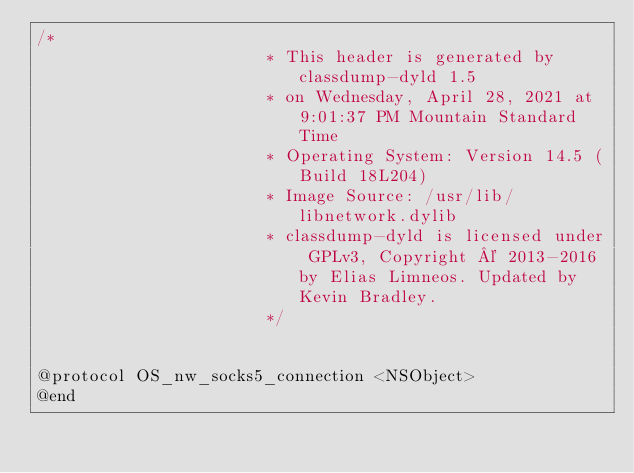Convert code to text. <code><loc_0><loc_0><loc_500><loc_500><_C_>/*
                       * This header is generated by classdump-dyld 1.5
                       * on Wednesday, April 28, 2021 at 9:01:37 PM Mountain Standard Time
                       * Operating System: Version 14.5 (Build 18L204)
                       * Image Source: /usr/lib/libnetwork.dylib
                       * classdump-dyld is licensed under GPLv3, Copyright © 2013-2016 by Elias Limneos. Updated by Kevin Bradley.
                       */


@protocol OS_nw_socks5_connection <NSObject>
@end

</code> 